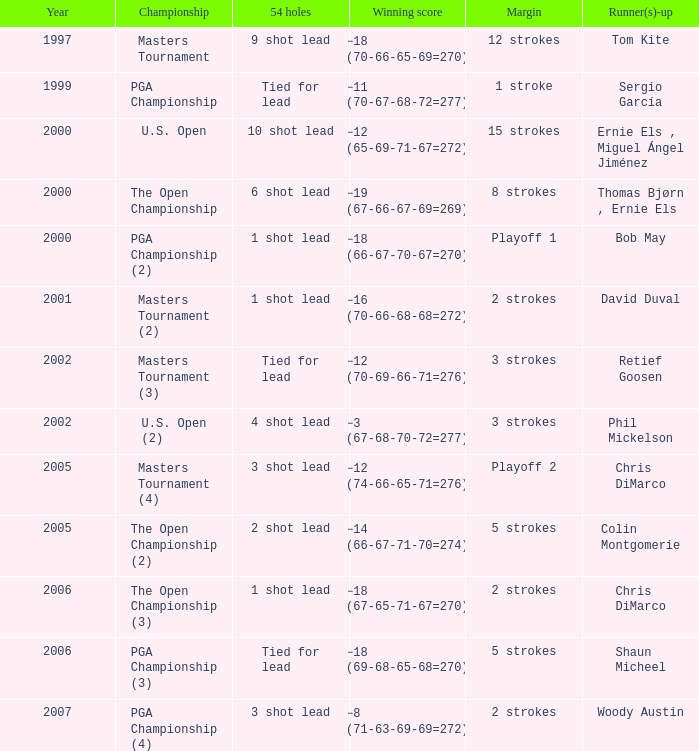Write the full table. {'header': ['Year', 'Championship', '54 holes', 'Winning score', 'Margin', 'Runner(s)-up'], 'rows': [['1997', 'Masters Tournament', '9 shot lead', '−18 (70-66-65-69=270)', '12 strokes', 'Tom Kite'], ['1999', 'PGA Championship', 'Tied for lead', '−11 (70-67-68-72=277)', '1 stroke', 'Sergio García'], ['2000', 'U.S. Open', '10 shot lead', '−12 (65-69-71-67=272)', '15 strokes', 'Ernie Els , Miguel Ángel Jiménez'], ['2000', 'The Open Championship', '6 shot lead', '−19 (67-66-67-69=269)', '8 strokes', 'Thomas Bjørn , Ernie Els'], ['2000', 'PGA Championship (2)', '1 shot lead', '−18 (66-67-70-67=270)', 'Playoff 1', 'Bob May'], ['2001', 'Masters Tournament (2)', '1 shot lead', '−16 (70-66-68-68=272)', '2 strokes', 'David Duval'], ['2002', 'Masters Tournament (3)', 'Tied for lead', '−12 (70-69-66-71=276)', '3 strokes', 'Retief Goosen'], ['2002', 'U.S. Open (2)', '4 shot lead', '−3 (67-68-70-72=277)', '3 strokes', 'Phil Mickelson'], ['2005', 'Masters Tournament (4)', '3 shot lead', '−12 (74-66-65-71=276)', 'Playoff 2', 'Chris DiMarco'], ['2005', 'The Open Championship (2)', '2 shot lead', '−14 (66-67-71-70=274)', '5 strokes', 'Colin Montgomerie'], ['2006', 'The Open Championship (3)', '1 shot lead', '−18 (67-65-71-67=270)', '2 strokes', 'Chris DiMarco'], ['2006', 'PGA Championship (3)', 'Tied for lead', '−18 (69-68-65-68=270)', '5 strokes', 'Shaun Micheel'], ['2007', 'PGA Championship (4)', '3 shot lead', '−8 (71-63-69-69=272)', '2 strokes', 'Woody Austin']]} What is the minimum year where winning score is −8 (71-63-69-69=272) 2007.0. 